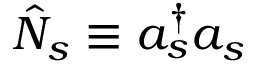<formula> <loc_0><loc_0><loc_500><loc_500>\hat { N } _ { s } \equiv a _ { s } ^ { \dag } a _ { s }</formula> 